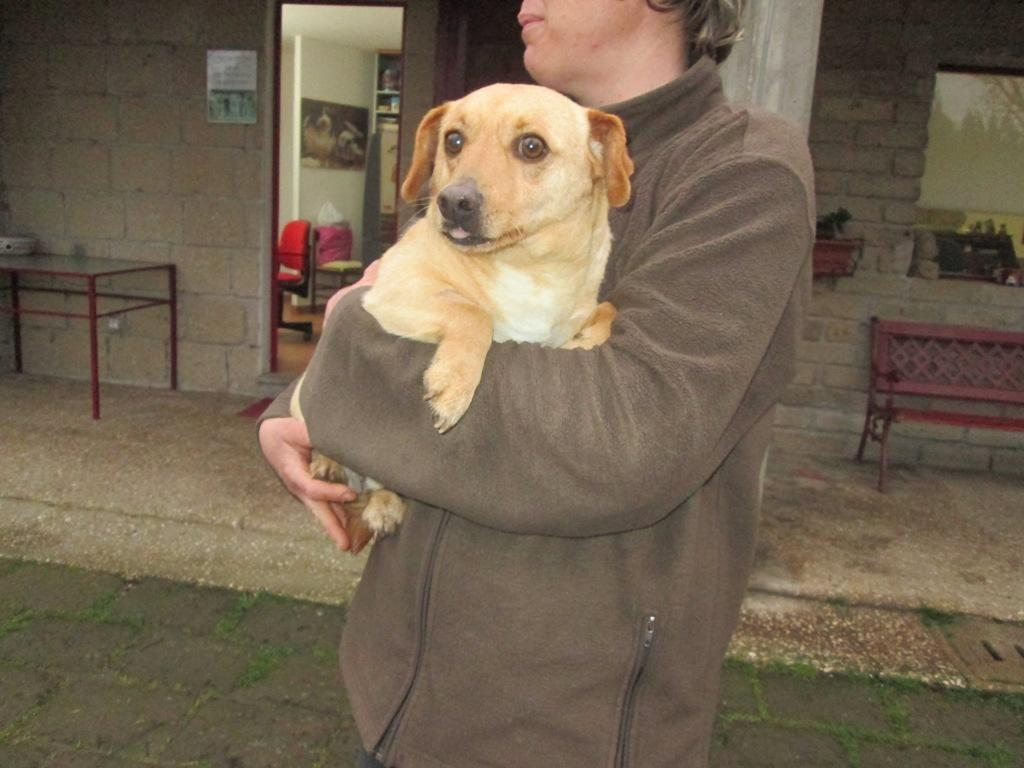What is the person in the image doing? The person is holding a dog in the image. What else can be seen in the image besides the person and the dog? There is a table, a building, and a bench in the background of the image. What type of pencil is being used to draw on the dog's fur in the image? There is no pencil or drawing activity present in the image; the person is simply holding the dog. 